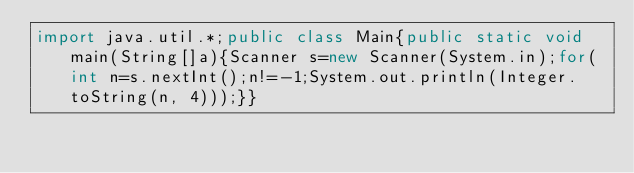<code> <loc_0><loc_0><loc_500><loc_500><_Java_>import java.util.*;public class Main{public static void main(String[]a){Scanner s=new Scanner(System.in);for(int n=s.nextInt();n!=-1;System.out.println(Integer.toString(n, 4)));}}</code> 